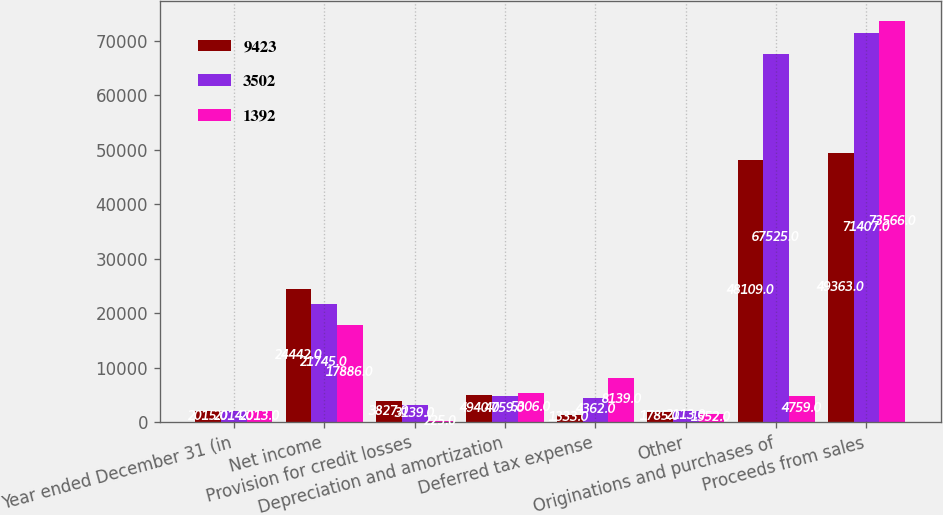<chart> <loc_0><loc_0><loc_500><loc_500><stacked_bar_chart><ecel><fcel>Year ended December 31 (in<fcel>Net income<fcel>Provision for credit losses<fcel>Depreciation and amortization<fcel>Deferred tax expense<fcel>Other<fcel>Originations and purchases of<fcel>Proceeds from sales<nl><fcel>9423<fcel>2015<fcel>24442<fcel>3827<fcel>4940<fcel>1333<fcel>1785<fcel>48109<fcel>49363<nl><fcel>3502<fcel>2014<fcel>21745<fcel>3139<fcel>4759<fcel>4362<fcel>2113<fcel>67525<fcel>71407<nl><fcel>1392<fcel>2013<fcel>17886<fcel>225<fcel>5306<fcel>8139<fcel>1552<fcel>4759<fcel>73566<nl></chart> 